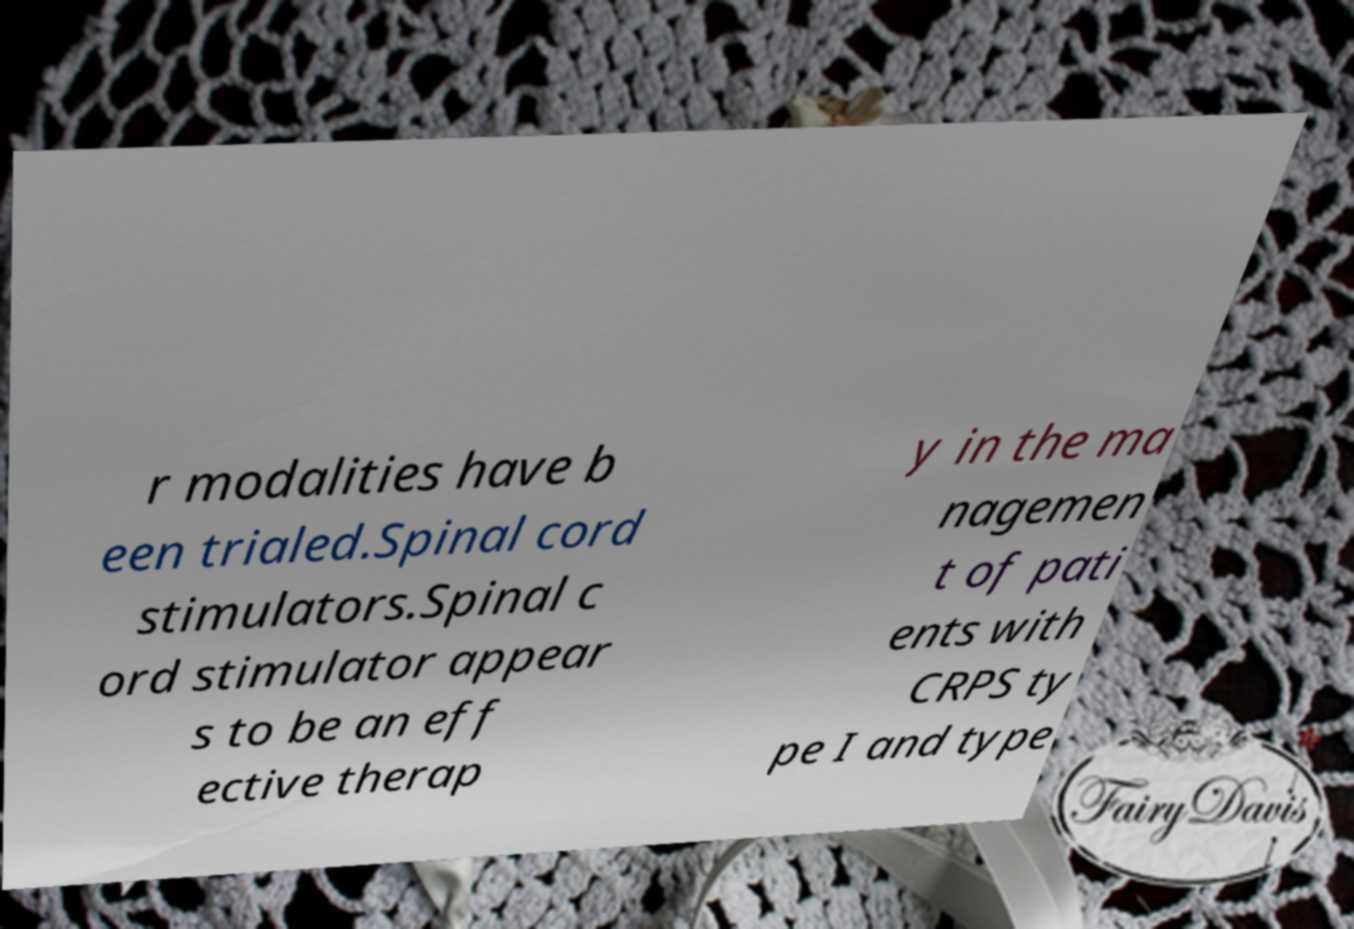There's text embedded in this image that I need extracted. Can you transcribe it verbatim? r modalities have b een trialed.Spinal cord stimulators.Spinal c ord stimulator appear s to be an eff ective therap y in the ma nagemen t of pati ents with CRPS ty pe I and type 